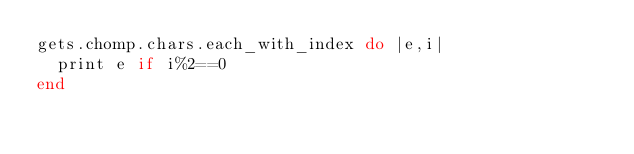<code> <loc_0><loc_0><loc_500><loc_500><_Ruby_>gets.chomp.chars.each_with_index do |e,i|
  print e if i%2==0
end</code> 